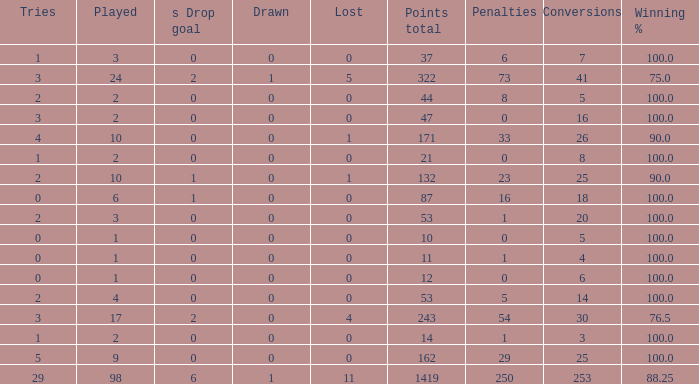What is the least number of penalties he got when his point total was over 1419 in more than 98 games? None. 